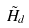<formula> <loc_0><loc_0><loc_500><loc_500>\tilde { H } _ { d }</formula> 